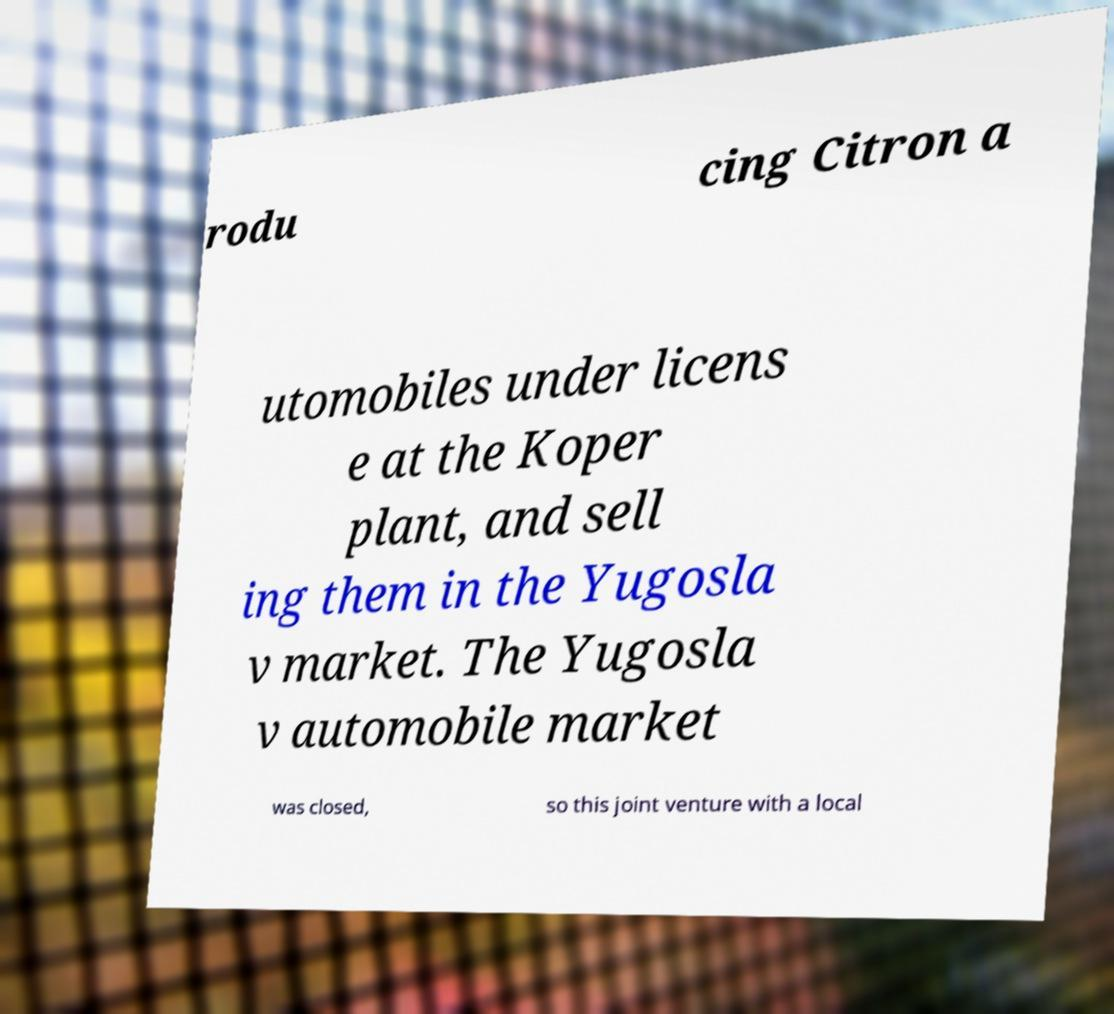There's text embedded in this image that I need extracted. Can you transcribe it verbatim? rodu cing Citron a utomobiles under licens e at the Koper plant, and sell ing them in the Yugosla v market. The Yugosla v automobile market was closed, so this joint venture with a local 